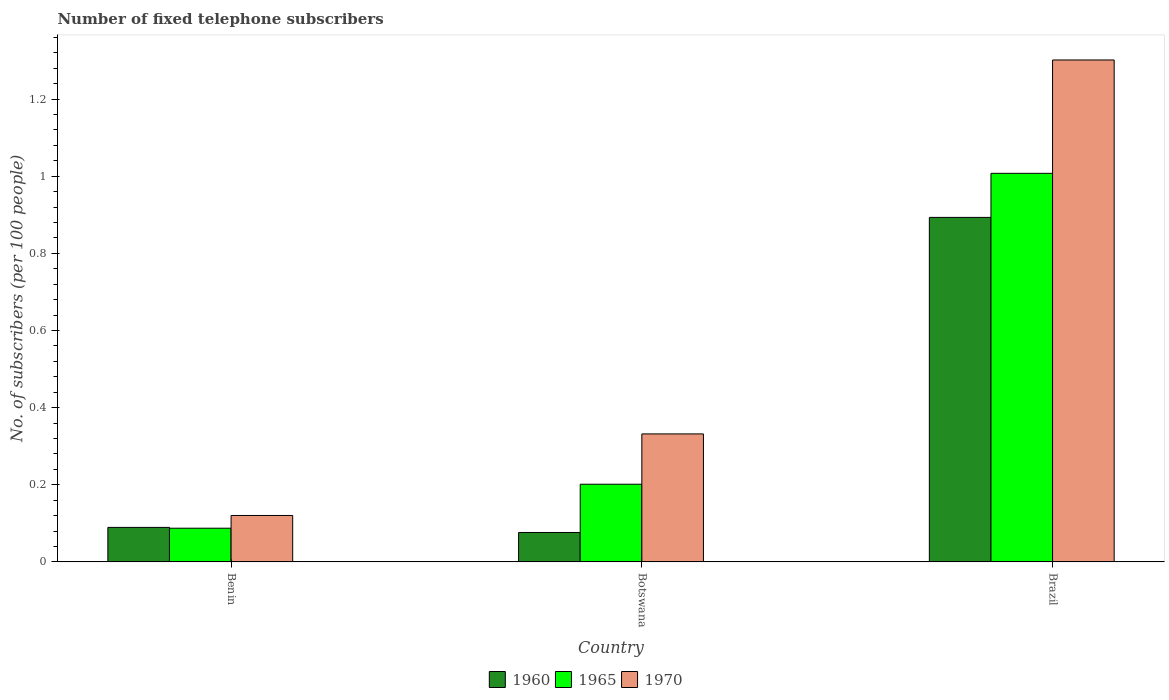How many groups of bars are there?
Make the answer very short. 3. Are the number of bars on each tick of the X-axis equal?
Offer a very short reply. Yes. How many bars are there on the 1st tick from the right?
Keep it short and to the point. 3. In how many cases, is the number of bars for a given country not equal to the number of legend labels?
Give a very brief answer. 0. What is the number of fixed telephone subscribers in 1960 in Benin?
Make the answer very short. 0.09. Across all countries, what is the maximum number of fixed telephone subscribers in 1965?
Your answer should be compact. 1.01. Across all countries, what is the minimum number of fixed telephone subscribers in 1965?
Make the answer very short. 0.09. In which country was the number of fixed telephone subscribers in 1960 minimum?
Your response must be concise. Botswana. What is the total number of fixed telephone subscribers in 1965 in the graph?
Make the answer very short. 1.3. What is the difference between the number of fixed telephone subscribers in 1965 in Benin and that in Brazil?
Your answer should be compact. -0.92. What is the difference between the number of fixed telephone subscribers in 1960 in Benin and the number of fixed telephone subscribers in 1965 in Botswana?
Your response must be concise. -0.11. What is the average number of fixed telephone subscribers in 1960 per country?
Offer a terse response. 0.35. What is the difference between the number of fixed telephone subscribers of/in 1960 and number of fixed telephone subscribers of/in 1965 in Brazil?
Give a very brief answer. -0.11. What is the ratio of the number of fixed telephone subscribers in 1970 in Benin to that in Botswana?
Give a very brief answer. 0.36. What is the difference between the highest and the second highest number of fixed telephone subscribers in 1965?
Your answer should be very brief. -0.81. What is the difference between the highest and the lowest number of fixed telephone subscribers in 1960?
Keep it short and to the point. 0.82. In how many countries, is the number of fixed telephone subscribers in 1960 greater than the average number of fixed telephone subscribers in 1960 taken over all countries?
Give a very brief answer. 1. Is the sum of the number of fixed telephone subscribers in 1960 in Benin and Brazil greater than the maximum number of fixed telephone subscribers in 1970 across all countries?
Provide a succinct answer. No. Are all the bars in the graph horizontal?
Your response must be concise. No. How many countries are there in the graph?
Your answer should be very brief. 3. What is the difference between two consecutive major ticks on the Y-axis?
Your answer should be very brief. 0.2. Are the values on the major ticks of Y-axis written in scientific E-notation?
Make the answer very short. No. Does the graph contain any zero values?
Give a very brief answer. No. Where does the legend appear in the graph?
Keep it short and to the point. Bottom center. How many legend labels are there?
Your answer should be compact. 3. How are the legend labels stacked?
Keep it short and to the point. Horizontal. What is the title of the graph?
Offer a terse response. Number of fixed telephone subscribers. What is the label or title of the Y-axis?
Your answer should be compact. No. of subscribers (per 100 people). What is the No. of subscribers (per 100 people) in 1960 in Benin?
Your answer should be very brief. 0.09. What is the No. of subscribers (per 100 people) of 1965 in Benin?
Offer a very short reply. 0.09. What is the No. of subscribers (per 100 people) in 1970 in Benin?
Provide a short and direct response. 0.12. What is the No. of subscribers (per 100 people) in 1960 in Botswana?
Your answer should be compact. 0.08. What is the No. of subscribers (per 100 people) of 1965 in Botswana?
Provide a succinct answer. 0.2. What is the No. of subscribers (per 100 people) of 1970 in Botswana?
Provide a succinct answer. 0.33. What is the No. of subscribers (per 100 people) in 1960 in Brazil?
Ensure brevity in your answer.  0.89. What is the No. of subscribers (per 100 people) in 1965 in Brazil?
Your response must be concise. 1.01. What is the No. of subscribers (per 100 people) of 1970 in Brazil?
Your answer should be compact. 1.3. Across all countries, what is the maximum No. of subscribers (per 100 people) of 1960?
Offer a very short reply. 0.89. Across all countries, what is the maximum No. of subscribers (per 100 people) of 1965?
Keep it short and to the point. 1.01. Across all countries, what is the maximum No. of subscribers (per 100 people) of 1970?
Give a very brief answer. 1.3. Across all countries, what is the minimum No. of subscribers (per 100 people) of 1960?
Your response must be concise. 0.08. Across all countries, what is the minimum No. of subscribers (per 100 people) in 1965?
Make the answer very short. 0.09. Across all countries, what is the minimum No. of subscribers (per 100 people) of 1970?
Provide a short and direct response. 0.12. What is the total No. of subscribers (per 100 people) of 1960 in the graph?
Give a very brief answer. 1.06. What is the total No. of subscribers (per 100 people) in 1965 in the graph?
Your answer should be compact. 1.3. What is the total No. of subscribers (per 100 people) of 1970 in the graph?
Provide a short and direct response. 1.75. What is the difference between the No. of subscribers (per 100 people) in 1960 in Benin and that in Botswana?
Offer a terse response. 0.01. What is the difference between the No. of subscribers (per 100 people) of 1965 in Benin and that in Botswana?
Give a very brief answer. -0.11. What is the difference between the No. of subscribers (per 100 people) in 1970 in Benin and that in Botswana?
Keep it short and to the point. -0.21. What is the difference between the No. of subscribers (per 100 people) in 1960 in Benin and that in Brazil?
Your answer should be compact. -0.8. What is the difference between the No. of subscribers (per 100 people) of 1965 in Benin and that in Brazil?
Ensure brevity in your answer.  -0.92. What is the difference between the No. of subscribers (per 100 people) of 1970 in Benin and that in Brazil?
Your answer should be compact. -1.18. What is the difference between the No. of subscribers (per 100 people) in 1960 in Botswana and that in Brazil?
Give a very brief answer. -0.82. What is the difference between the No. of subscribers (per 100 people) of 1965 in Botswana and that in Brazil?
Give a very brief answer. -0.81. What is the difference between the No. of subscribers (per 100 people) in 1970 in Botswana and that in Brazil?
Make the answer very short. -0.97. What is the difference between the No. of subscribers (per 100 people) of 1960 in Benin and the No. of subscribers (per 100 people) of 1965 in Botswana?
Provide a succinct answer. -0.11. What is the difference between the No. of subscribers (per 100 people) in 1960 in Benin and the No. of subscribers (per 100 people) in 1970 in Botswana?
Provide a succinct answer. -0.24. What is the difference between the No. of subscribers (per 100 people) in 1965 in Benin and the No. of subscribers (per 100 people) in 1970 in Botswana?
Give a very brief answer. -0.24. What is the difference between the No. of subscribers (per 100 people) in 1960 in Benin and the No. of subscribers (per 100 people) in 1965 in Brazil?
Offer a very short reply. -0.92. What is the difference between the No. of subscribers (per 100 people) of 1960 in Benin and the No. of subscribers (per 100 people) of 1970 in Brazil?
Provide a succinct answer. -1.21. What is the difference between the No. of subscribers (per 100 people) of 1965 in Benin and the No. of subscribers (per 100 people) of 1970 in Brazil?
Offer a very short reply. -1.21. What is the difference between the No. of subscribers (per 100 people) of 1960 in Botswana and the No. of subscribers (per 100 people) of 1965 in Brazil?
Keep it short and to the point. -0.93. What is the difference between the No. of subscribers (per 100 people) of 1960 in Botswana and the No. of subscribers (per 100 people) of 1970 in Brazil?
Offer a terse response. -1.23. What is the difference between the No. of subscribers (per 100 people) in 1965 in Botswana and the No. of subscribers (per 100 people) in 1970 in Brazil?
Keep it short and to the point. -1.1. What is the average No. of subscribers (per 100 people) in 1960 per country?
Provide a short and direct response. 0.35. What is the average No. of subscribers (per 100 people) of 1965 per country?
Provide a succinct answer. 0.43. What is the average No. of subscribers (per 100 people) of 1970 per country?
Ensure brevity in your answer.  0.58. What is the difference between the No. of subscribers (per 100 people) in 1960 and No. of subscribers (per 100 people) in 1965 in Benin?
Your answer should be compact. 0. What is the difference between the No. of subscribers (per 100 people) of 1960 and No. of subscribers (per 100 people) of 1970 in Benin?
Make the answer very short. -0.03. What is the difference between the No. of subscribers (per 100 people) of 1965 and No. of subscribers (per 100 people) of 1970 in Benin?
Ensure brevity in your answer.  -0.03. What is the difference between the No. of subscribers (per 100 people) in 1960 and No. of subscribers (per 100 people) in 1965 in Botswana?
Make the answer very short. -0.13. What is the difference between the No. of subscribers (per 100 people) of 1960 and No. of subscribers (per 100 people) of 1970 in Botswana?
Offer a very short reply. -0.26. What is the difference between the No. of subscribers (per 100 people) in 1965 and No. of subscribers (per 100 people) in 1970 in Botswana?
Your response must be concise. -0.13. What is the difference between the No. of subscribers (per 100 people) of 1960 and No. of subscribers (per 100 people) of 1965 in Brazil?
Give a very brief answer. -0.11. What is the difference between the No. of subscribers (per 100 people) of 1960 and No. of subscribers (per 100 people) of 1970 in Brazil?
Your response must be concise. -0.41. What is the difference between the No. of subscribers (per 100 people) of 1965 and No. of subscribers (per 100 people) of 1970 in Brazil?
Keep it short and to the point. -0.29. What is the ratio of the No. of subscribers (per 100 people) in 1960 in Benin to that in Botswana?
Keep it short and to the point. 1.17. What is the ratio of the No. of subscribers (per 100 people) of 1965 in Benin to that in Botswana?
Your answer should be very brief. 0.43. What is the ratio of the No. of subscribers (per 100 people) of 1970 in Benin to that in Botswana?
Offer a terse response. 0.36. What is the ratio of the No. of subscribers (per 100 people) in 1960 in Benin to that in Brazil?
Provide a succinct answer. 0.1. What is the ratio of the No. of subscribers (per 100 people) of 1965 in Benin to that in Brazil?
Make the answer very short. 0.09. What is the ratio of the No. of subscribers (per 100 people) of 1970 in Benin to that in Brazil?
Provide a succinct answer. 0.09. What is the ratio of the No. of subscribers (per 100 people) of 1960 in Botswana to that in Brazil?
Your answer should be compact. 0.09. What is the ratio of the No. of subscribers (per 100 people) in 1965 in Botswana to that in Brazil?
Make the answer very short. 0.2. What is the ratio of the No. of subscribers (per 100 people) in 1970 in Botswana to that in Brazil?
Your answer should be compact. 0.26. What is the difference between the highest and the second highest No. of subscribers (per 100 people) in 1960?
Give a very brief answer. 0.8. What is the difference between the highest and the second highest No. of subscribers (per 100 people) of 1965?
Give a very brief answer. 0.81. What is the difference between the highest and the second highest No. of subscribers (per 100 people) in 1970?
Ensure brevity in your answer.  0.97. What is the difference between the highest and the lowest No. of subscribers (per 100 people) of 1960?
Your answer should be very brief. 0.82. What is the difference between the highest and the lowest No. of subscribers (per 100 people) in 1965?
Your response must be concise. 0.92. What is the difference between the highest and the lowest No. of subscribers (per 100 people) of 1970?
Your response must be concise. 1.18. 